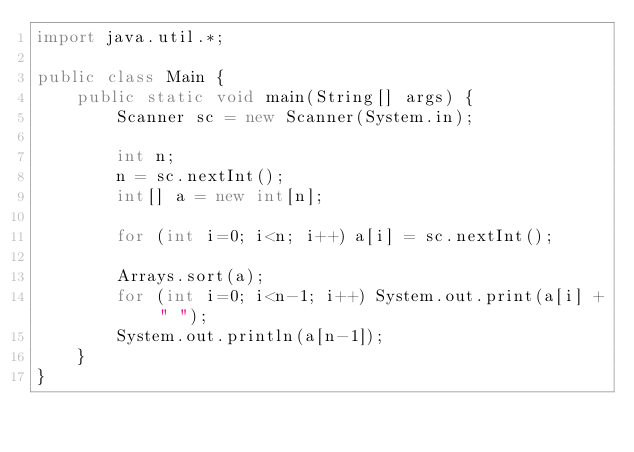<code> <loc_0><loc_0><loc_500><loc_500><_Java_>import java.util.*;

public class Main {
    public static void main(String[] args) {
        Scanner sc = new Scanner(System.in);

        int n;
        n = sc.nextInt();
        int[] a = new int[n];

        for (int i=0; i<n; i++) a[i] = sc.nextInt();

        Arrays.sort(a);
        for (int i=0; i<n-1; i++) System.out.print(a[i] + " ");
        System.out.println(a[n-1]);
    }
}</code> 